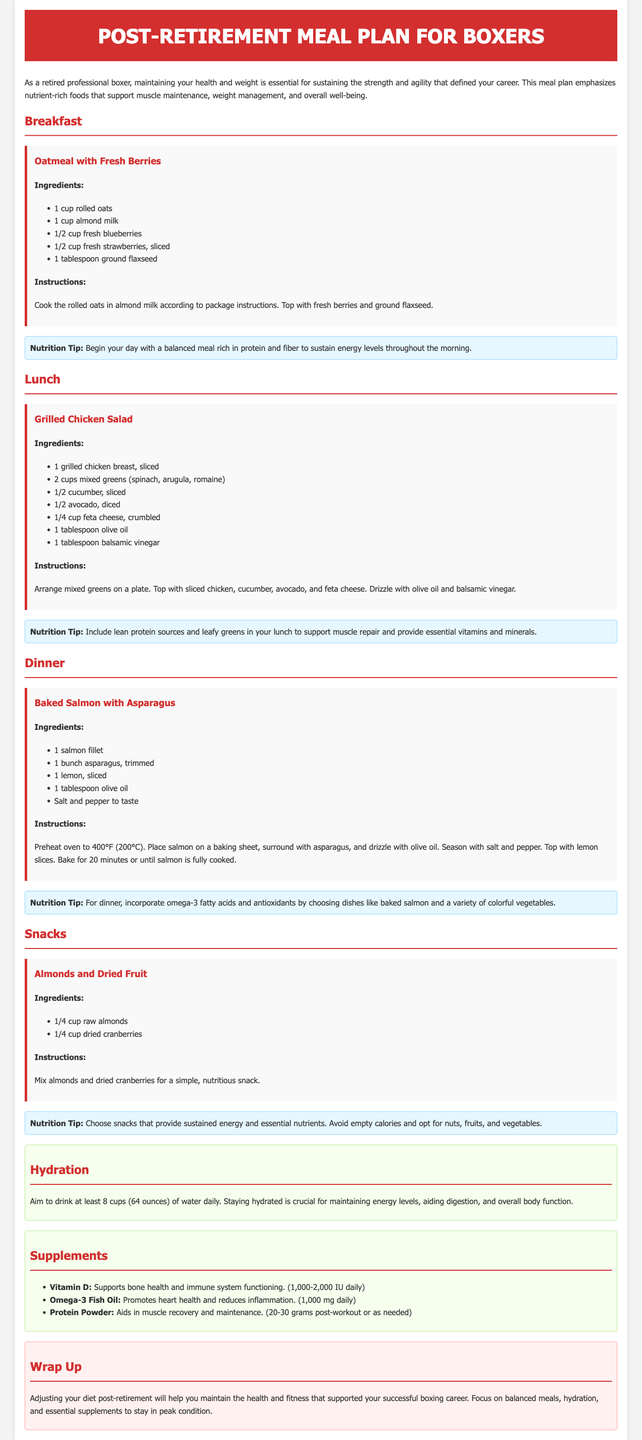What is the first meal in the plan? The first meal listed in the document is breakfast, specifically "Oatmeal with Fresh Berries."
Answer: Oatmeal with Fresh Berries What type of oil is used in the Grilled Chicken Salad? The recipe for Grilled Chicken Salad includes "1 tablespoon olive oil."
Answer: Olive oil How many cups of water should you aim to drink daily? The document states to "Aim to drink at least 8 cups (64 ounces) of water daily."
Answer: 8 cups What is the main protein source in the dinner meal? The dinner meal features "1 salmon fillet" as the main protein source.
Answer: Salmon fillet What is one nutrition tip mentioned for breakfast? The nutrition tip for breakfast advises to "Begin your day with a balanced meal rich in protein and fiber."
Answer: Protein and fiber How many grams of protein powder should be taken post-workout? The document suggests "20-30 grams post-workout or as needed" for protein powder.
Answer: 20-30 grams Which snack includes nuts and dried fruit? The snack listed in the document is "Almonds and Dried Fruit."
Answer: Almonds and Dried Fruit What vegetable accompanies the baked salmon dish? The baked salmon meal is served with "1 bunch asparagus."
Answer: Asparagus 